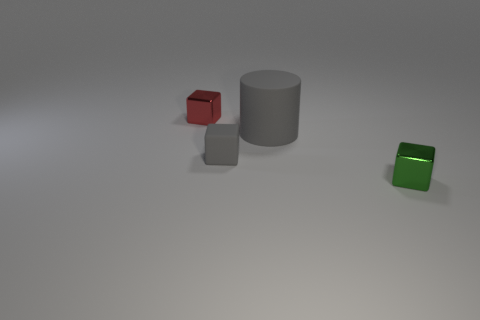Subtract all tiny red metallic cubes. How many cubes are left? 2 Subtract all red cubes. How many cubes are left? 2 Add 4 big blue rubber cylinders. How many objects exist? 8 Subtract 1 cylinders. How many cylinders are left? 0 Subtract all blue blocks. Subtract all green balls. How many blocks are left? 3 Subtract all green blocks. How many red cylinders are left? 0 Subtract all small red metal blocks. Subtract all red cylinders. How many objects are left? 3 Add 4 green objects. How many green objects are left? 5 Add 4 small gray rubber cubes. How many small gray rubber cubes exist? 5 Subtract 0 green balls. How many objects are left? 4 